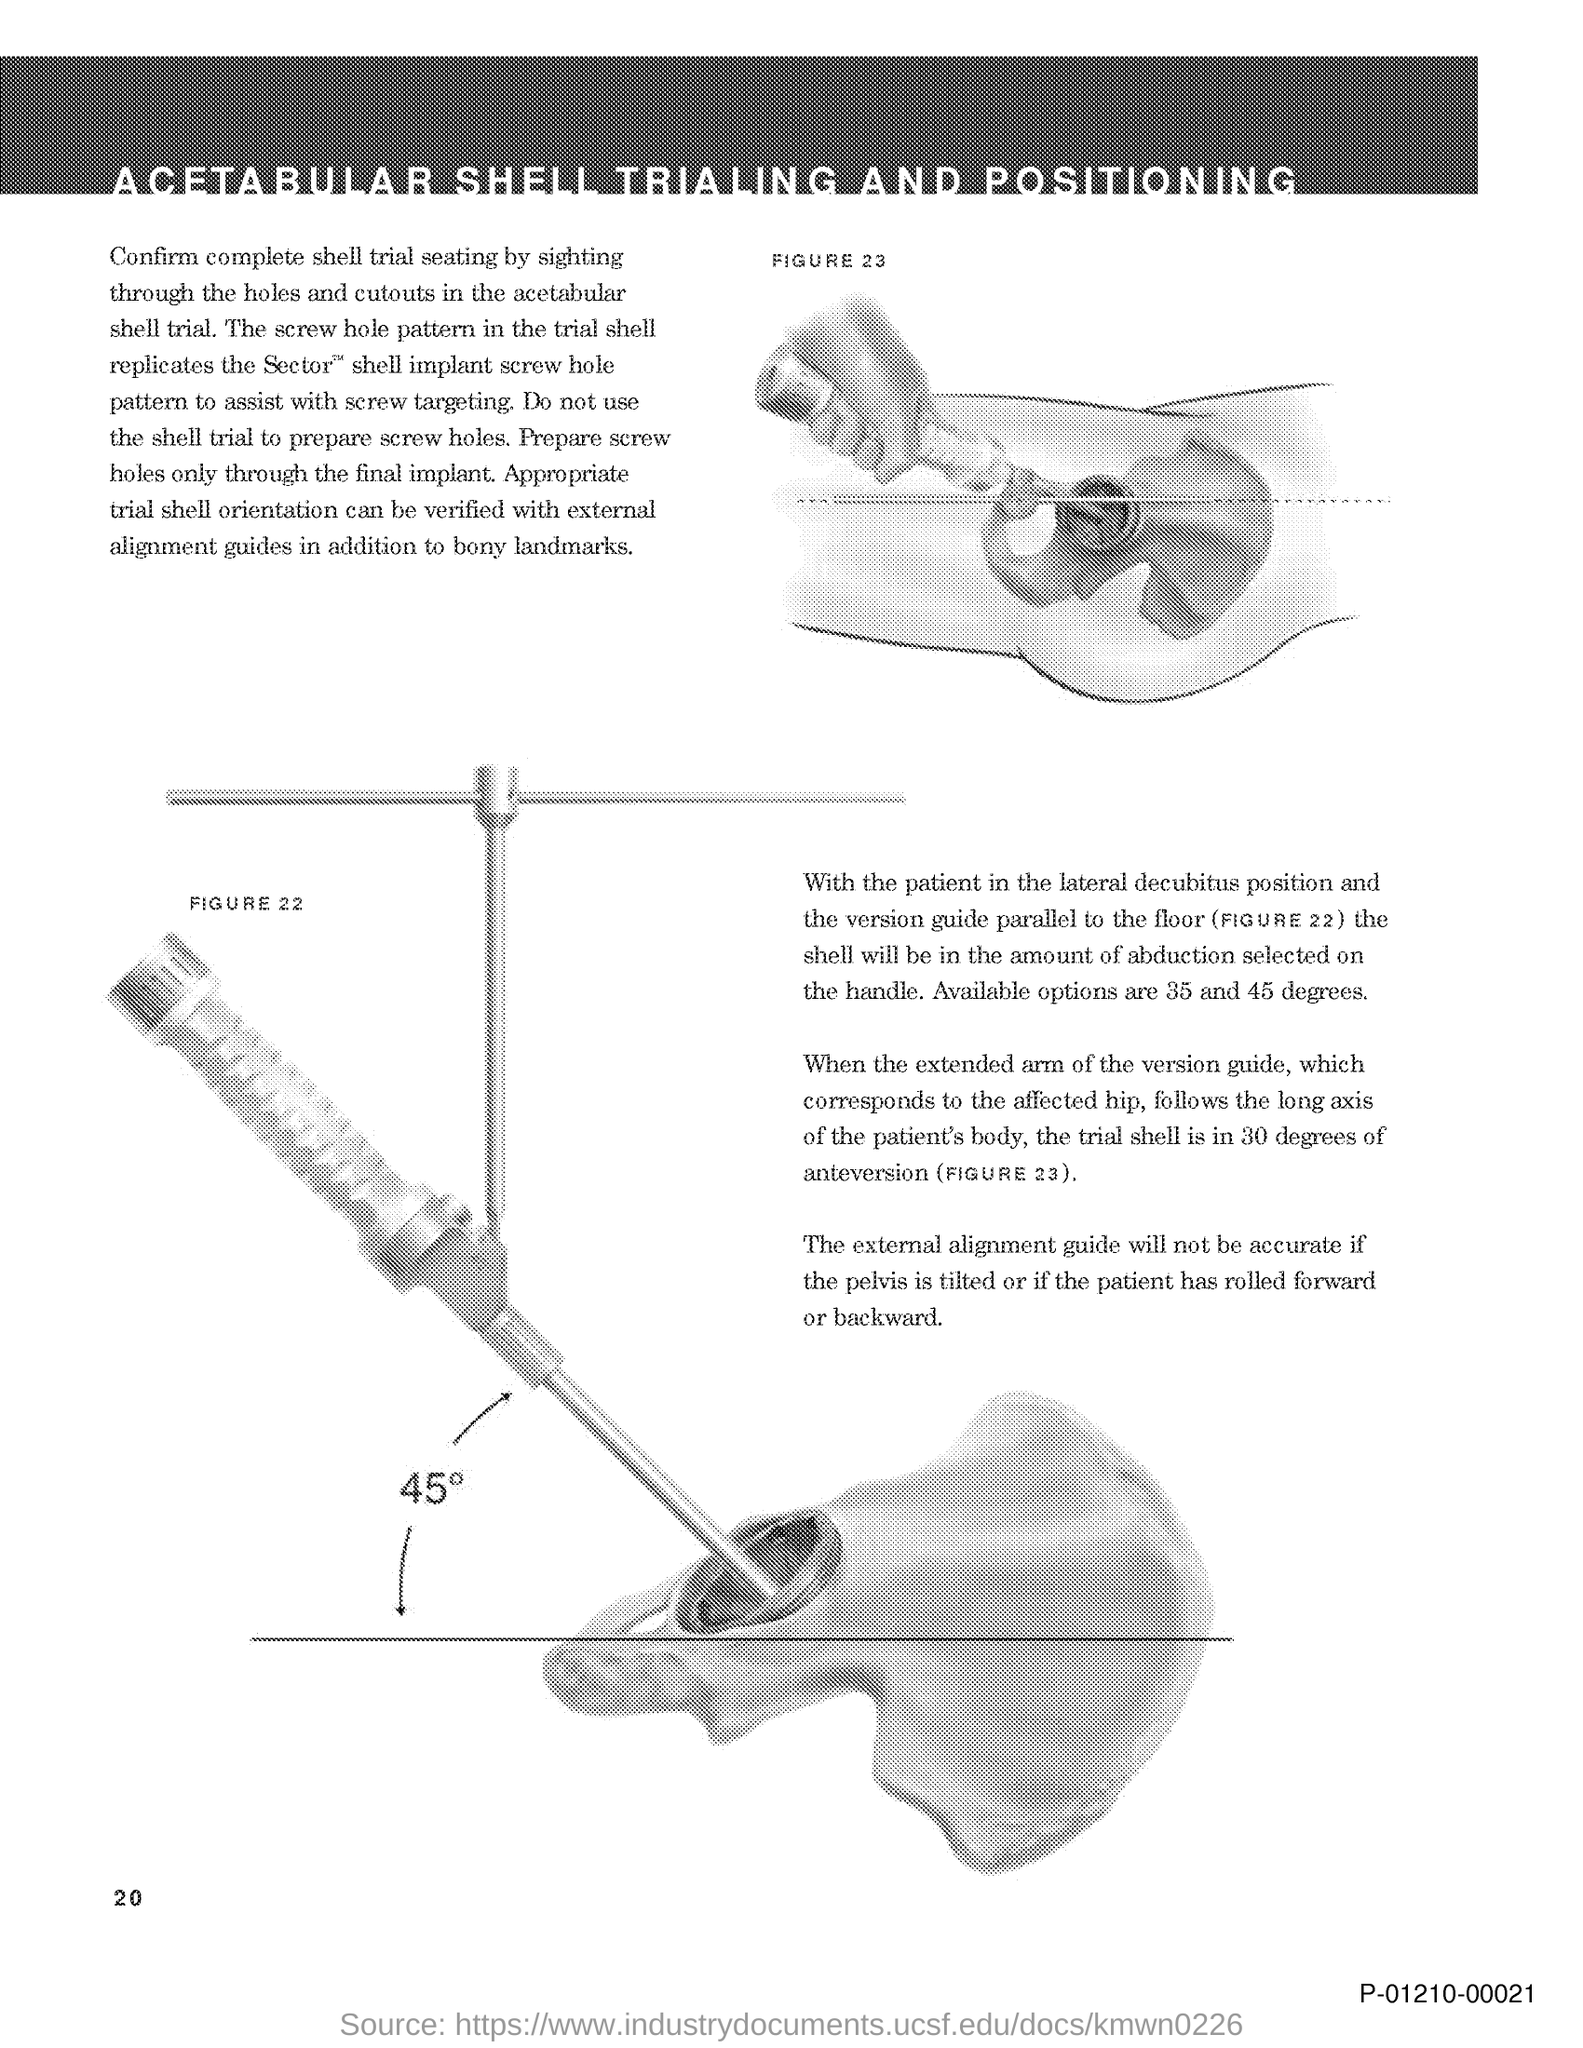Why does the screw hole pattern in the trial shell replicate the Sector shell implant screw hole pattern
Keep it short and to the point. To assist with screw targeting. How can the appropriate trial shell orientation be verified?
Your answer should be very brief. With external alignment guides in addition to bony landmarks. What are the amounts of abduction available for selection?
Offer a very short reply. 35 and 45 degrees. When will the shell be in the amount of abduction selected on the handle?
Your answer should be very brief. With the patient in the lateral decubitus position and the version guide parallel to the floor. 